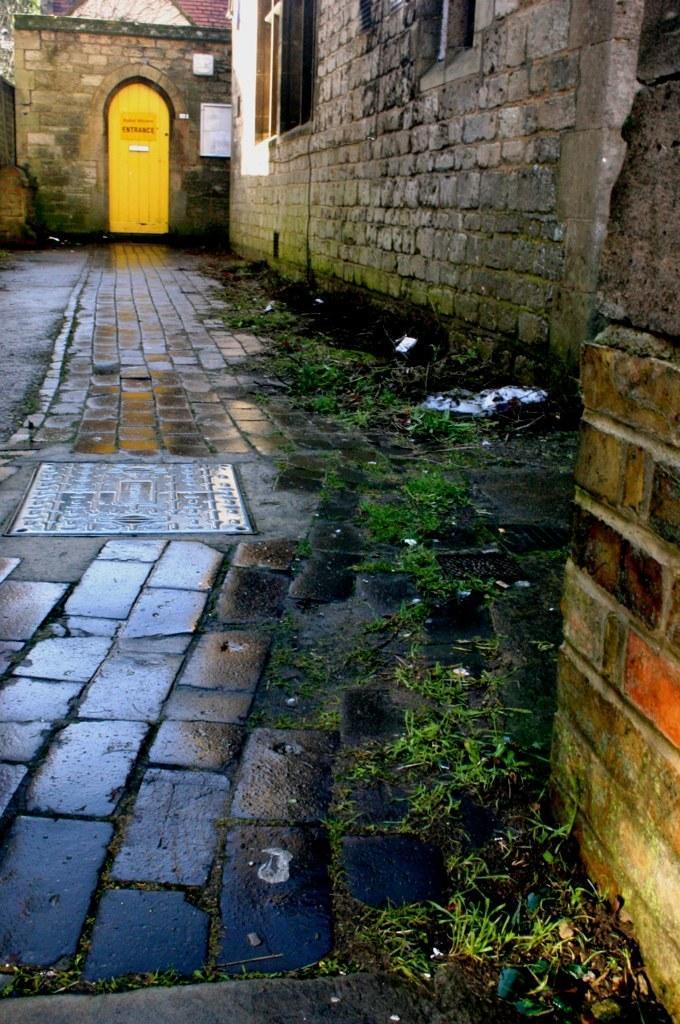How would you summarize this image in a sentence or two? In this image there is a path, on the right side there is are walls, in the background there is a house. 